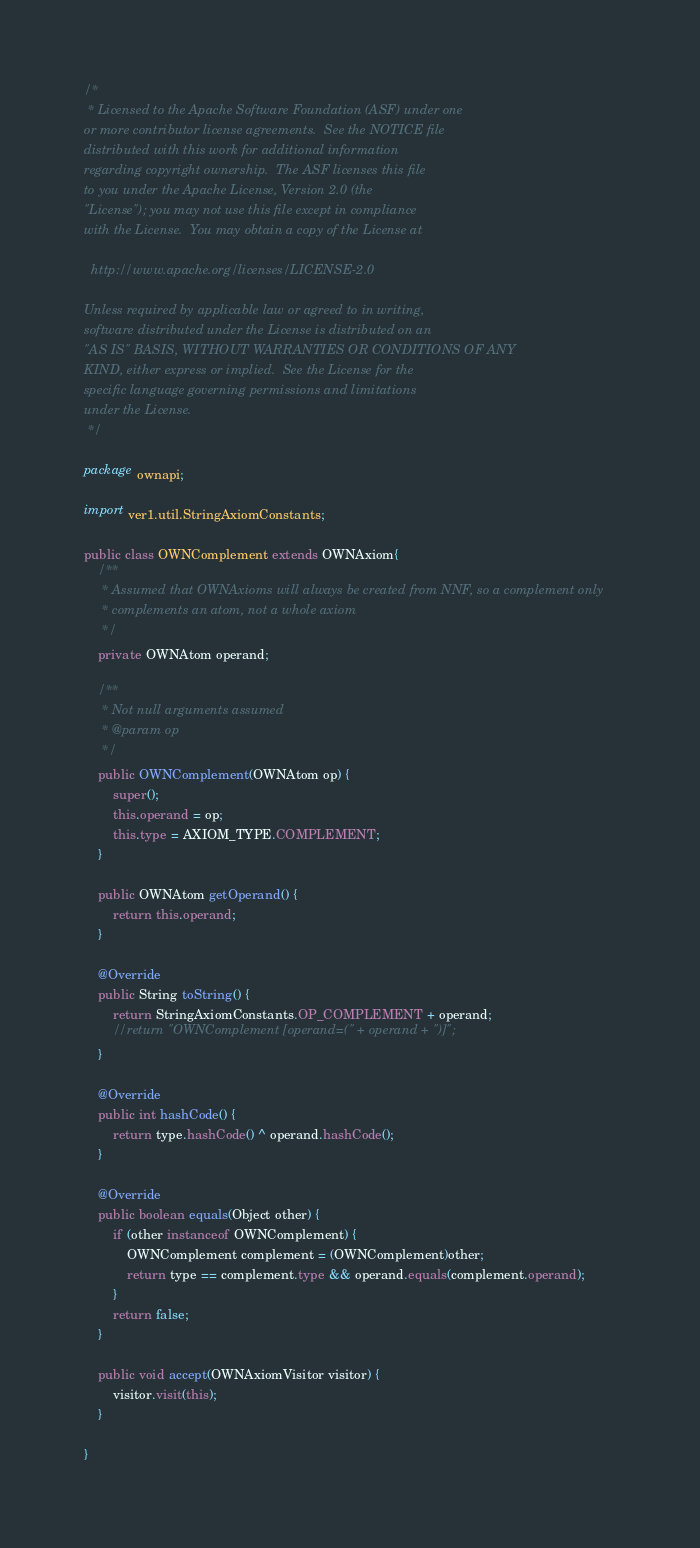<code> <loc_0><loc_0><loc_500><loc_500><_Java_>/*
 * Licensed to the Apache Software Foundation (ASF) under one
or more contributor license agreements.  See the NOTICE file
distributed with this work for additional information
regarding copyright ownership.  The ASF licenses this file
to you under the Apache License, Version 2.0 (the
"License"); you may not use this file except in compliance
with the License.  You may obtain a copy of the License at

  http://www.apache.org/licenses/LICENSE-2.0

Unless required by applicable law or agreed to in writing,
software distributed under the License is distributed on an
"AS IS" BASIS, WITHOUT WARRANTIES OR CONDITIONS OF ANY
KIND, either express or implied.  See the License for the
specific language governing permissions and limitations
under the License.
 */

package ownapi;

import ver1.util.StringAxiomConstants;

public class OWNComplement extends OWNAxiom{
	/**
	 * Assumed that OWNAxioms will always be created from NNF, so a complement only
	 * complements an atom, not a whole axiom
	 */
	private OWNAtom operand;
	
	/**
	 * Not null arguments assumed
	 * @param op
	 */
	public OWNComplement(OWNAtom op) {
		super();
		this.operand = op;
		this.type = AXIOM_TYPE.COMPLEMENT;
	}
	
	public OWNAtom getOperand() {
		return this.operand;
	}

	@Override
	public String toString() {
		return StringAxiomConstants.OP_COMPLEMENT + operand;
		//return "OWNComplement [operand=(" + operand + ")]";
	}
	
	@Override
	public int hashCode() {
		return type.hashCode() ^ operand.hashCode();
	}
	
	@Override
	public boolean equals(Object other) {
		if (other instanceof OWNComplement) {
			OWNComplement complement = (OWNComplement)other;
			return type == complement.type && operand.equals(complement.operand);
		}
		return false;
	}
	
	public void accept(OWNAxiomVisitor visitor) {
		visitor.visit(this);
	}

}
</code> 